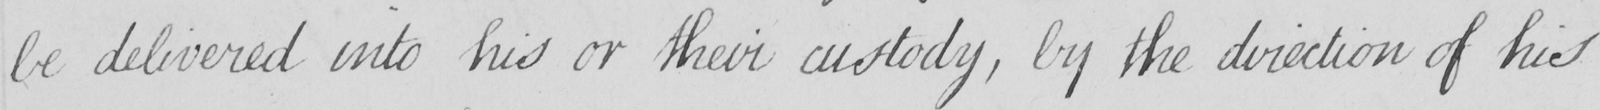Can you tell me what this handwritten text says? be delivered into his or their custody , by the direction of his 